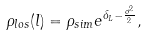<formula> <loc_0><loc_0><loc_500><loc_500>\rho _ { l o s } ( l ) = \rho _ { s i m } e ^ { \delta _ { L } - \frac { \sigma ^ { 2 } } { 2 } } ,</formula> 